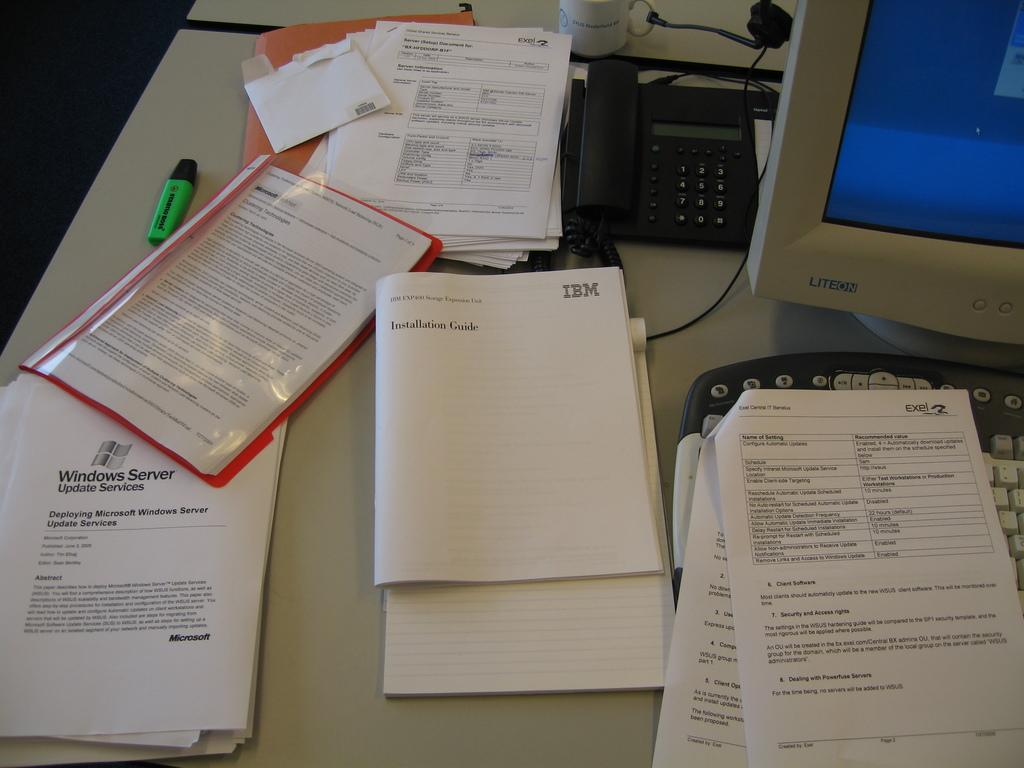Provide a one-sentence caption for the provided image. a booklet that says 'installation guide' on it. 